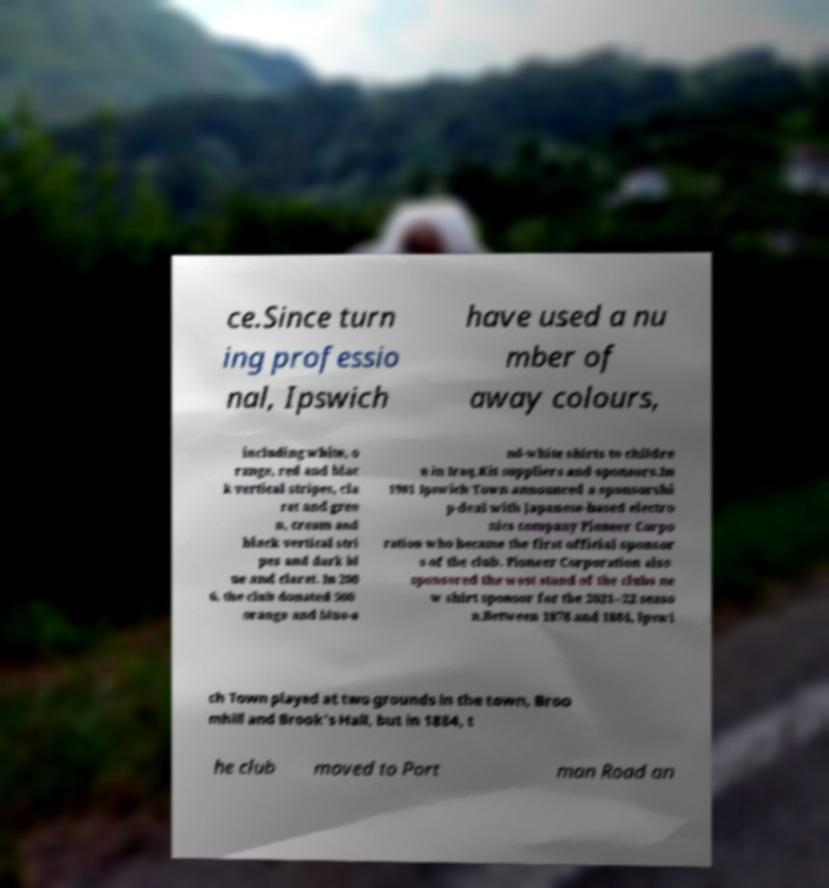I need the written content from this picture converted into text. Can you do that? ce.Since turn ing professio nal, Ipswich have used a nu mber of away colours, including white, o range, red and blac k vertical stripes, cla ret and gree n, cream and black vertical stri pes and dark bl ue and claret. In 200 6, the club donated 500 orange and blue-a nd-white shirts to childre n in Iraq.Kit suppliers and sponsors.In 1981 Ipswich Town announced a sponsorshi p deal with Japanese-based electro nics company Pioneer Corpo ration who became the first official sponsor s of the club. Pioneer Corporation also sponsored the west stand of the clubs ne w shirt sponsor for the 2021–22 seaso n.Between 1878 and 1884, Ipswi ch Town played at two grounds in the town, Broo mhill and Brook's Hall, but in 1884, t he club moved to Port man Road an 